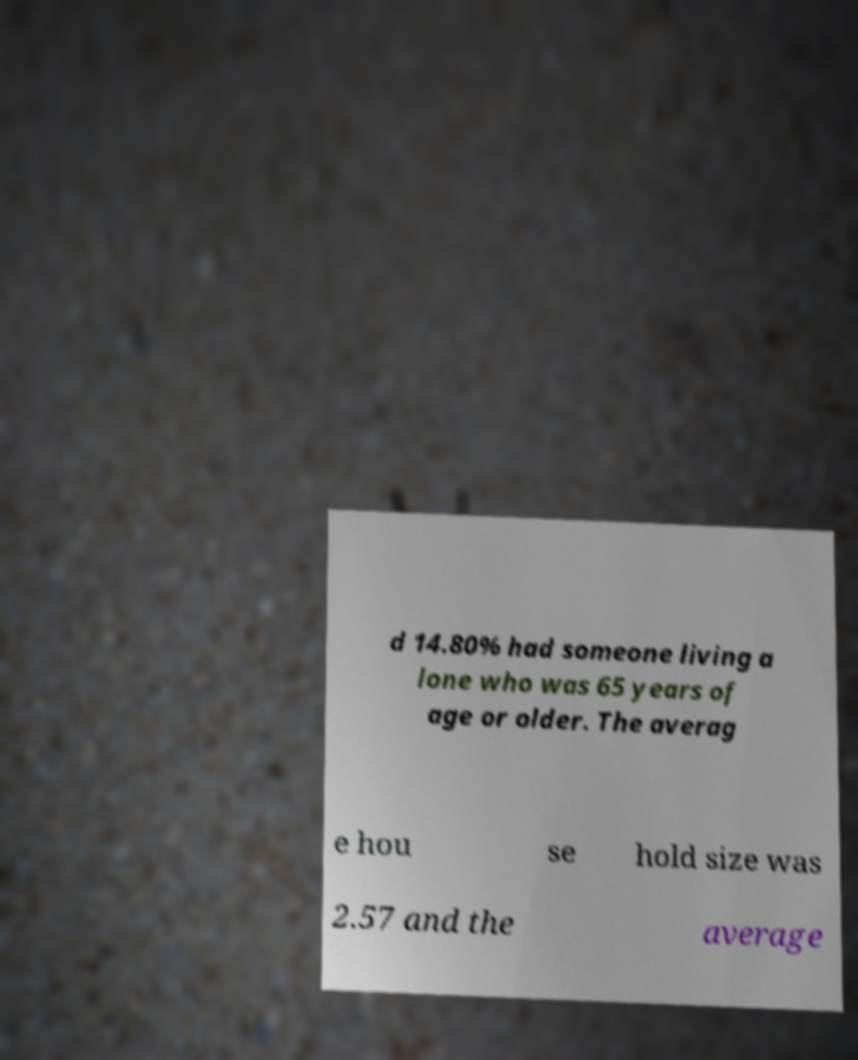Can you accurately transcribe the text from the provided image for me? d 14.80% had someone living a lone who was 65 years of age or older. The averag e hou se hold size was 2.57 and the average 